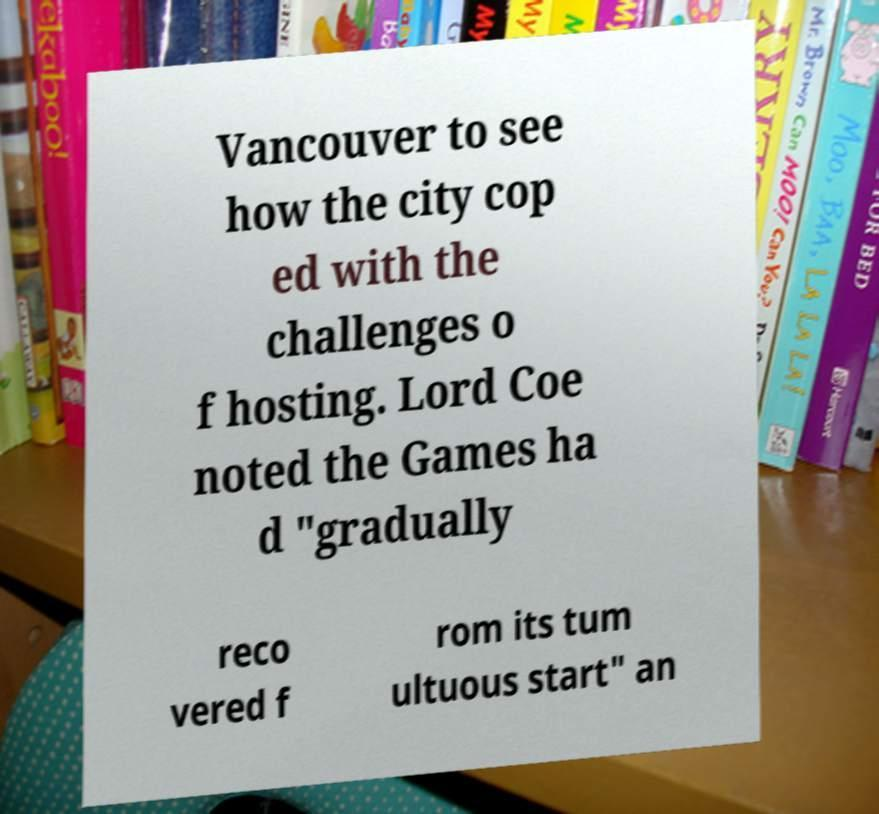Could you assist in decoding the text presented in this image and type it out clearly? Vancouver to see how the city cop ed with the challenges o f hosting. Lord Coe noted the Games ha d "gradually reco vered f rom its tum ultuous start" an 